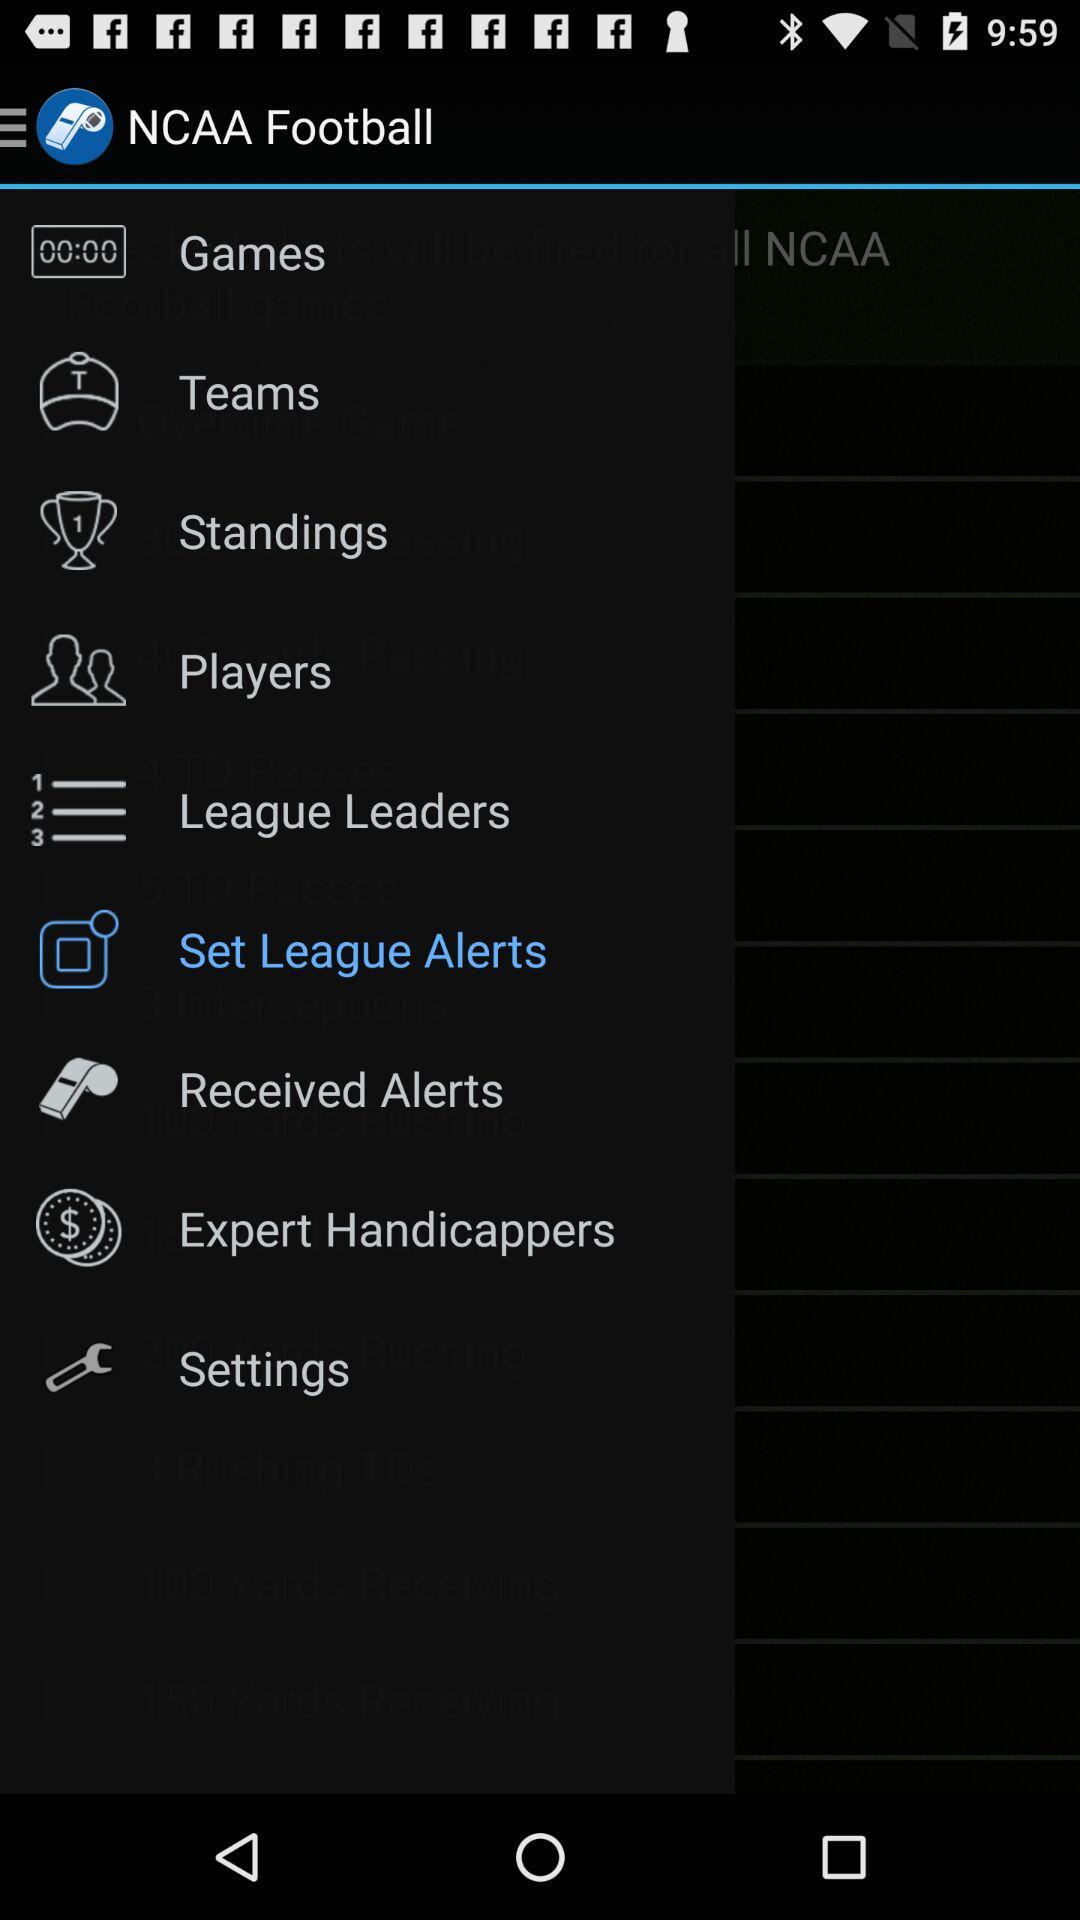What is the name of the application? The name of the application is "NCAA Football". 